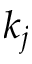Convert formula to latex. <formula><loc_0><loc_0><loc_500><loc_500>k _ { j }</formula> 